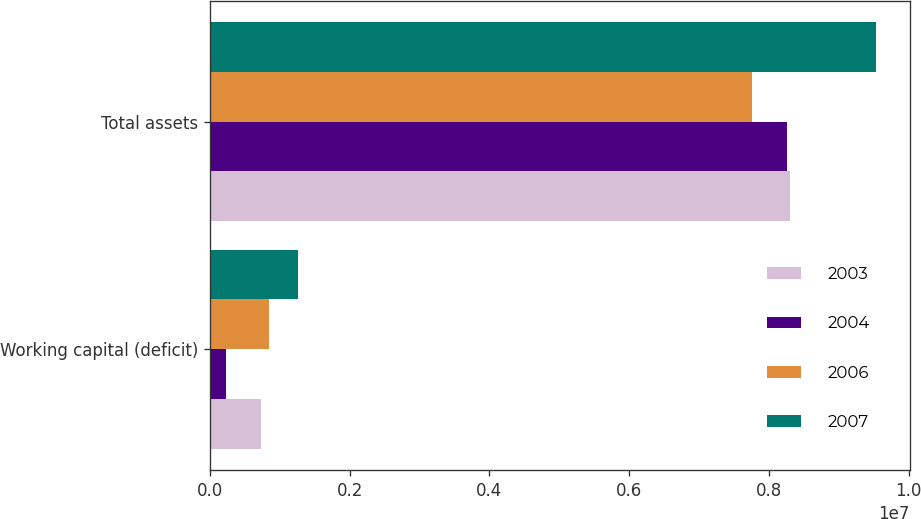<chart> <loc_0><loc_0><loc_500><loc_500><stacked_bar_chart><ecel><fcel>Working capital (deficit)<fcel>Total assets<nl><fcel>2003<fcel>728697<fcel>8.29542e+06<nl><fcel>2004<fcel>224770<fcel>8.26432e+06<nl><fcel>2006<fcel>847981<fcel>7.75689e+06<nl><fcel>2007<fcel>1.26368e+06<fcel>9.53719e+06<nl></chart> 